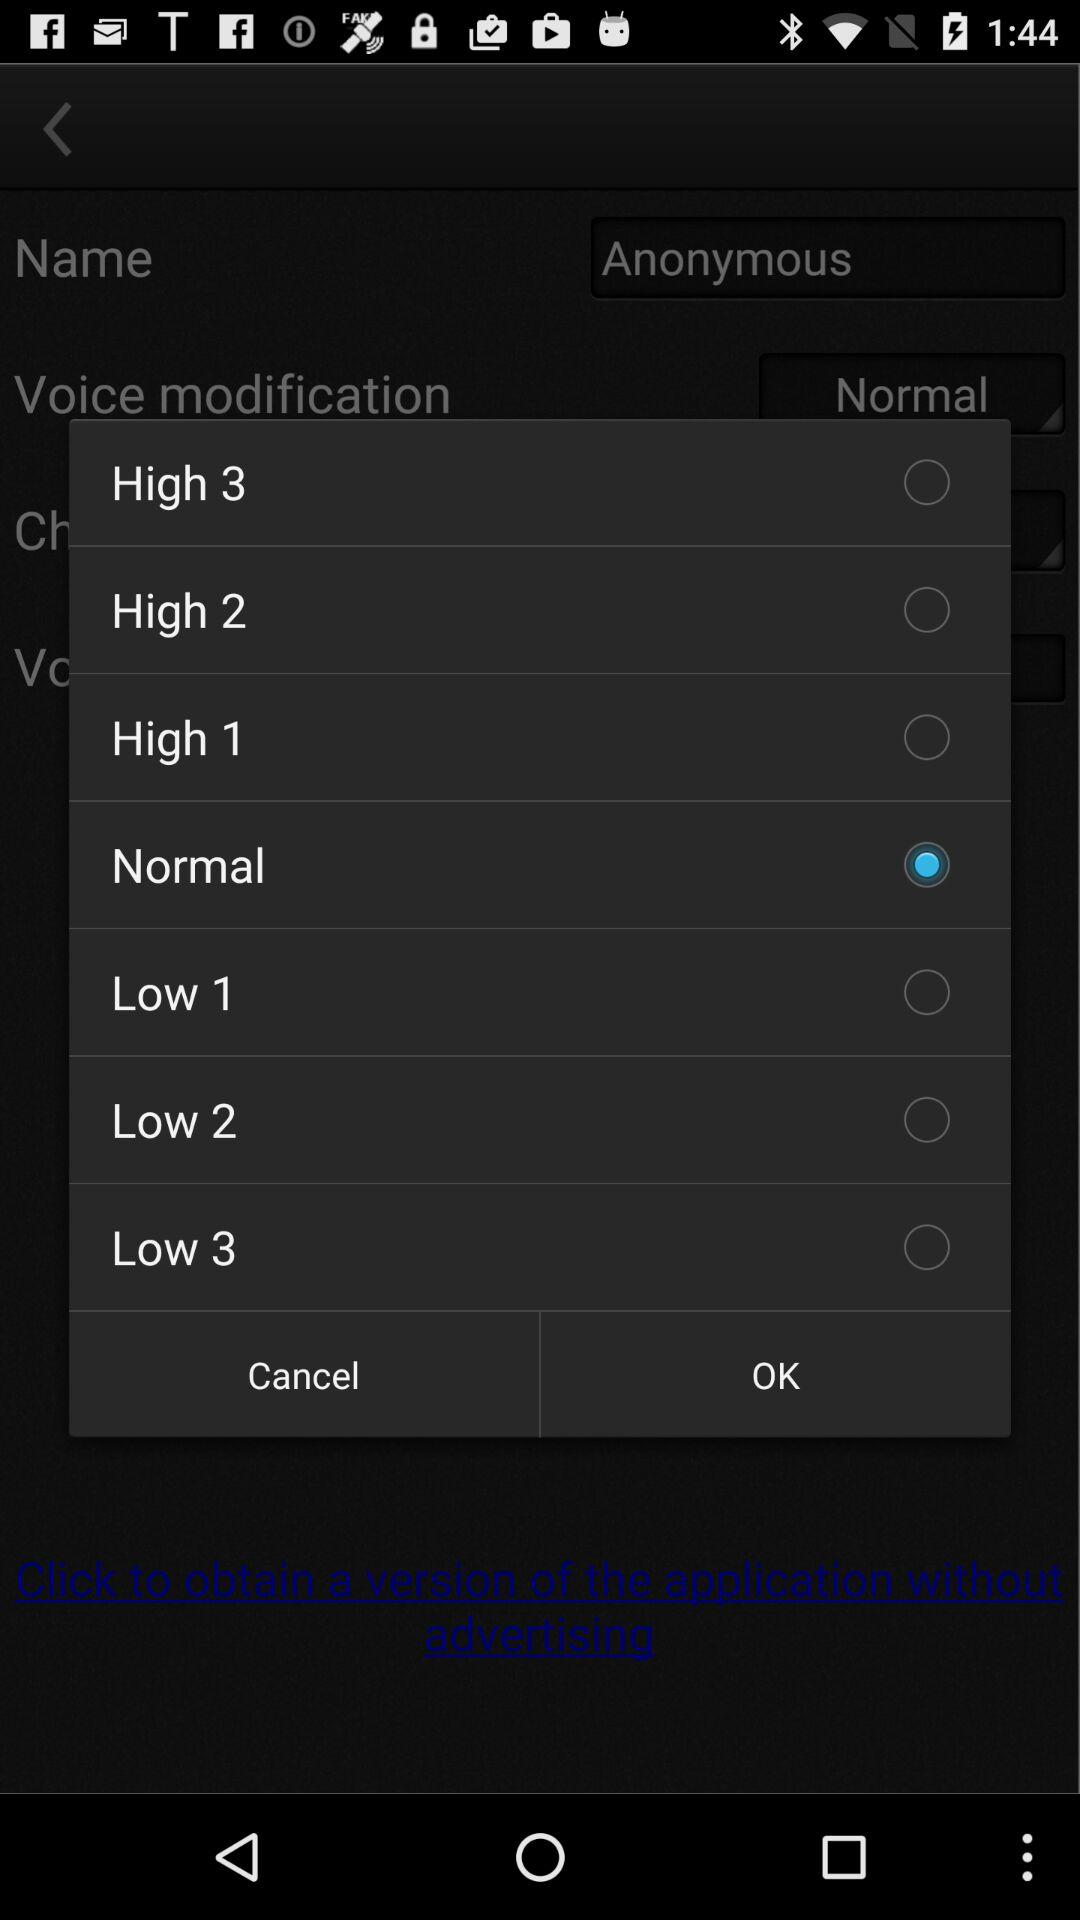Which option is selected? The selected option is "Normal". 